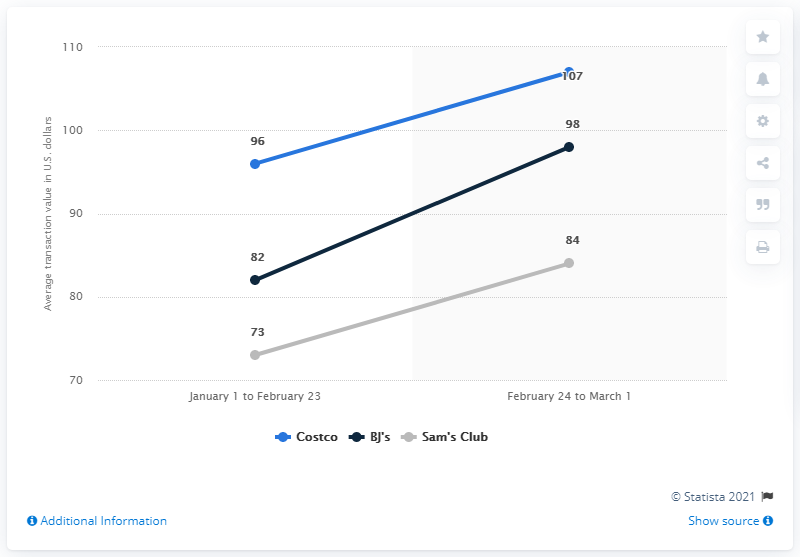Mention a couple of crucial points in this snapshot. The average transaction value at BJ's Wholesale Clubs from January 1 to February 23 was approximately $98 per transaction. The average transaction value across wholesale club retailers increased from January 1 to February 23. From January 1 to February 23, the average transaction value at BJ's Wholesale Clubs was $82. Between January 1 and February 23, the average transaction value for wholesale club retailers increased. 